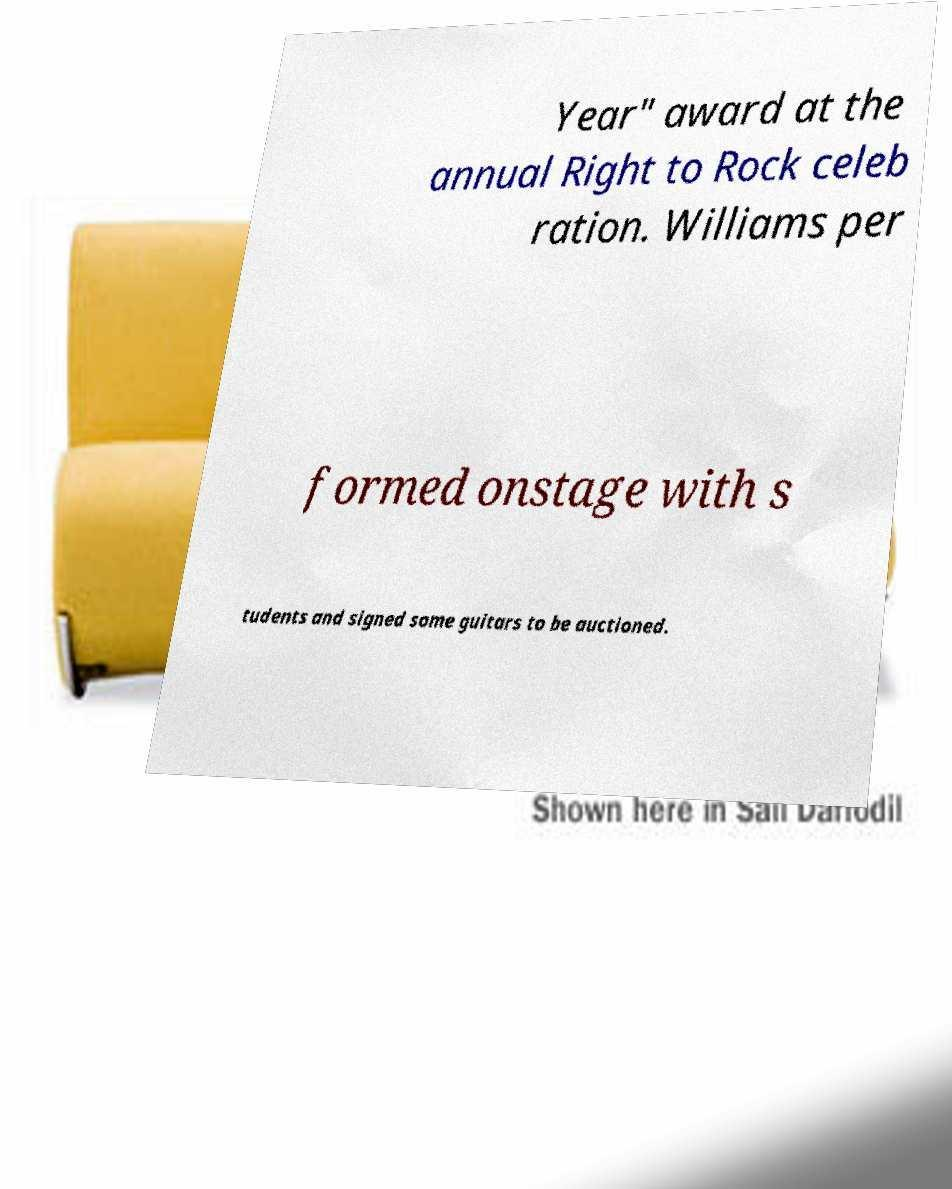What messages or text are displayed in this image? I need them in a readable, typed format. Year" award at the annual Right to Rock celeb ration. Williams per formed onstage with s tudents and signed some guitars to be auctioned. 